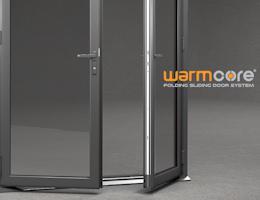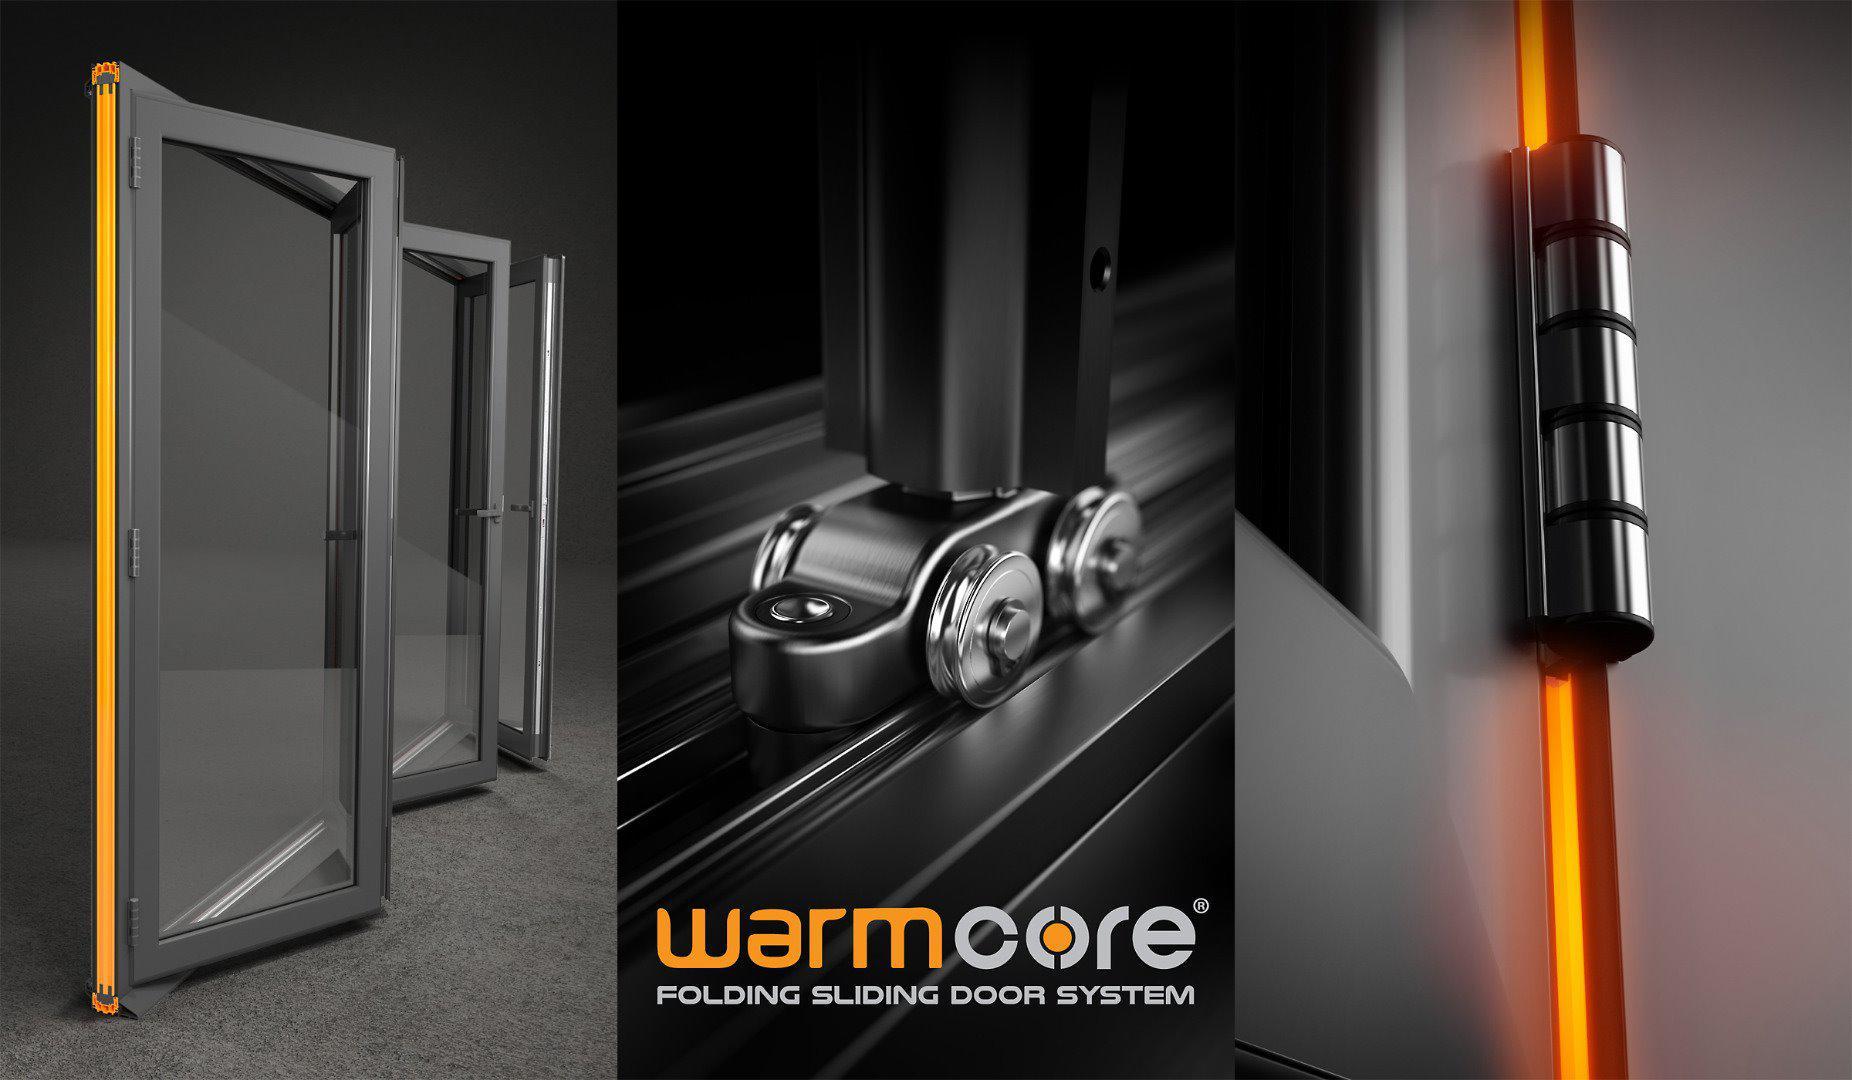The first image is the image on the left, the second image is the image on the right. Given the left and right images, does the statement "An image shows a glass door unit with at least three panels and with a handle on the rightmost door, flanked by bricks of different colors and viewed at an angle." hold true? Answer yes or no. No. The first image is the image on the left, the second image is the image on the right. For the images shown, is this caption "The doors in the left image are closed." true? Answer yes or no. No. 